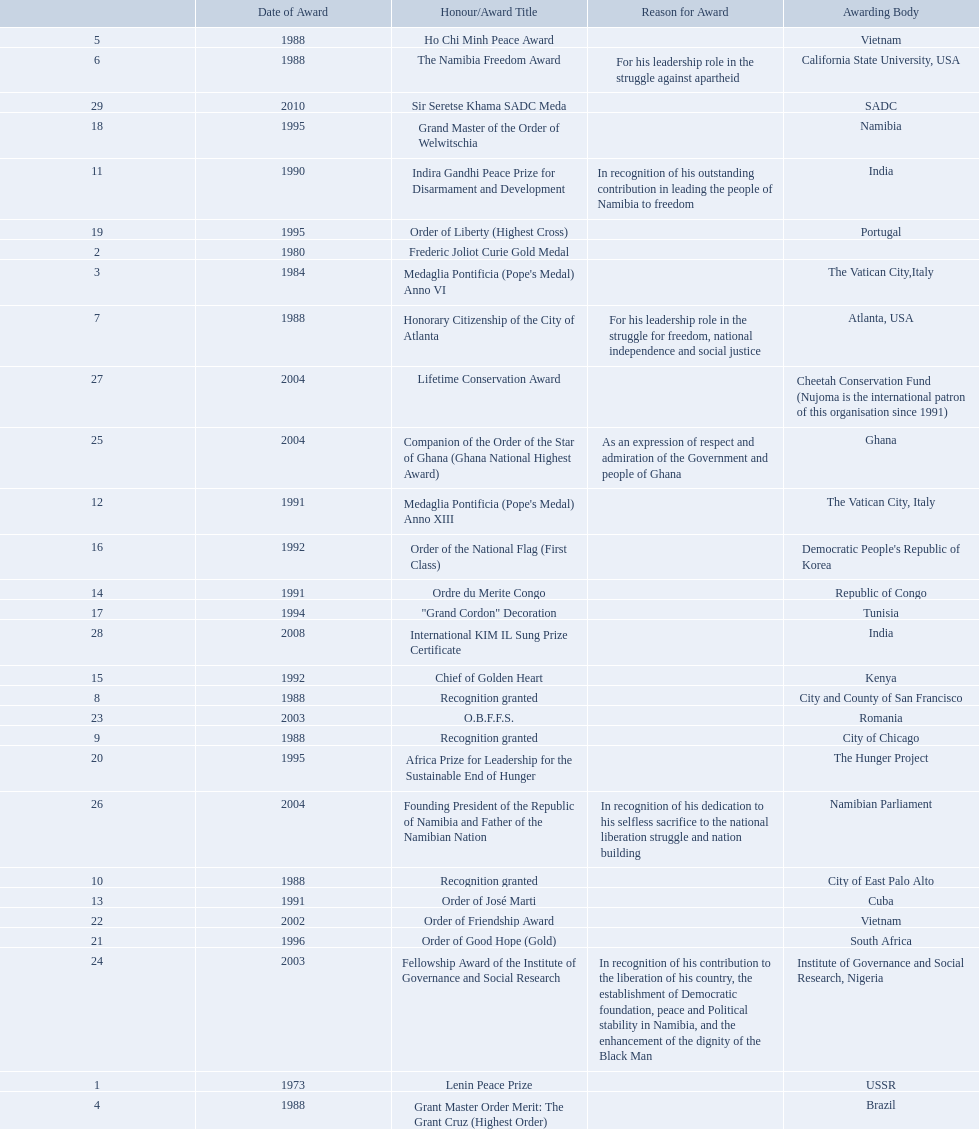Which awarding bodies have recognized sam nujoma? USSR, , The Vatican City,Italy, Brazil, Vietnam, California State University, USA, Atlanta, USA, City and County of San Francisco, City of Chicago, City of East Palo Alto, India, The Vatican City, Italy, Cuba, Republic of Congo, Kenya, Democratic People's Republic of Korea, Tunisia, Namibia, Portugal, The Hunger Project, South Africa, Vietnam, Romania, Institute of Governance and Social Research, Nigeria, Ghana, Namibian Parliament, Cheetah Conservation Fund (Nujoma is the international patron of this organisation since 1991), India, SADC. And what was the title of each award or honour? Lenin Peace Prize, Frederic Joliot Curie Gold Medal, Medaglia Pontificia (Pope's Medal) Anno VI, Grant Master Order Merit: The Grant Cruz (Highest Order), Ho Chi Minh Peace Award, The Namibia Freedom Award, Honorary Citizenship of the City of Atlanta, Recognition granted, Recognition granted, Recognition granted, Indira Gandhi Peace Prize for Disarmament and Development, Medaglia Pontificia (Pope's Medal) Anno XIII, Order of José Marti, Ordre du Merite Congo, Chief of Golden Heart, Order of the National Flag (First Class), "Grand Cordon" Decoration, Grand Master of the Order of Welwitschia, Order of Liberty (Highest Cross), Africa Prize for Leadership for the Sustainable End of Hunger, Order of Good Hope (Gold), Order of Friendship Award, O.B.F.F.S., Fellowship Award of the Institute of Governance and Social Research, Companion of the Order of the Star of Ghana (Ghana National Highest Award), Founding President of the Republic of Namibia and Father of the Namibian Nation, Lifetime Conservation Award, International KIM IL Sung Prize Certificate, Sir Seretse Khama SADC Meda. Of those, which nation awarded him the o.b.f.f.s.? Romania. Can you parse all the data within this table? {'header': ['', 'Date of Award', 'Honour/Award Title', 'Reason for Award', 'Awarding Body'], 'rows': [['5', '1988', 'Ho Chi Minh Peace Award', '', 'Vietnam'], ['6', '1988', 'The Namibia Freedom Award', 'For his leadership role in the struggle against apartheid', 'California State University, USA'], ['29', '2010', 'Sir Seretse Khama SADC Meda', '', 'SADC'], ['18', '1995', 'Grand Master of the Order of Welwitschia', '', 'Namibia'], ['11', '1990', 'Indira Gandhi Peace Prize for Disarmament and Development', 'In recognition of his outstanding contribution in leading the people of Namibia to freedom', 'India'], ['19', '1995', 'Order of Liberty (Highest Cross)', '', 'Portugal'], ['2', '1980', 'Frederic Joliot Curie Gold Medal', '', ''], ['3', '1984', "Medaglia Pontificia (Pope's Medal) Anno VI", '', 'The Vatican City,Italy'], ['7', '1988', 'Honorary Citizenship of the City of Atlanta', 'For his leadership role in the struggle for freedom, national independence and social justice', 'Atlanta, USA'], ['27', '2004', 'Lifetime Conservation Award', '', 'Cheetah Conservation Fund (Nujoma is the international patron of this organisation since 1991)'], ['25', '2004', 'Companion of the Order of the Star of Ghana (Ghana National Highest Award)', 'As an expression of respect and admiration of the Government and people of Ghana', 'Ghana'], ['12', '1991', "Medaglia Pontificia (Pope's Medal) Anno XIII", '', 'The Vatican City, Italy'], ['16', '1992', 'Order of the National Flag (First Class)', '', "Democratic People's Republic of Korea"], ['14', '1991', 'Ordre du Merite Congo', '', 'Republic of Congo'], ['17', '1994', '"Grand Cordon" Decoration', '', 'Tunisia'], ['28', '2008', 'International KIM IL Sung Prize Certificate', '', 'India'], ['15', '1992', 'Chief of Golden Heart', '', 'Kenya'], ['8', '1988', 'Recognition granted', '', 'City and County of San Francisco'], ['23', '2003', 'O.B.F.F.S.', '', 'Romania'], ['9', '1988', 'Recognition granted', '', 'City of Chicago'], ['20', '1995', 'Africa Prize for Leadership for the Sustainable End of Hunger', '', 'The Hunger Project'], ['26', '2004', 'Founding President of the Republic of Namibia and Father of the Namibian Nation', 'In recognition of his dedication to his selfless sacrifice to the national liberation struggle and nation building', 'Namibian Parliament'], ['10', '1988', 'Recognition granted', '', 'City of East Palo Alto'], ['13', '1991', 'Order of José Marti', '', 'Cuba'], ['22', '2002', 'Order of Friendship Award', '', 'Vietnam'], ['21', '1996', 'Order of Good Hope (Gold)', '', 'South Africa'], ['24', '2003', 'Fellowship Award of the Institute of Governance and Social Research', 'In recognition of his contribution to the liberation of his country, the establishment of Democratic foundation, peace and Political stability in Namibia, and the enhancement of the dignity of the Black Man', 'Institute of Governance and Social Research, Nigeria'], ['1', '1973', 'Lenin Peace Prize', '', 'USSR'], ['4', '1988', 'Grant Master Order Merit: The Grant Cruz (Highest Order)', '', 'Brazil']]} 